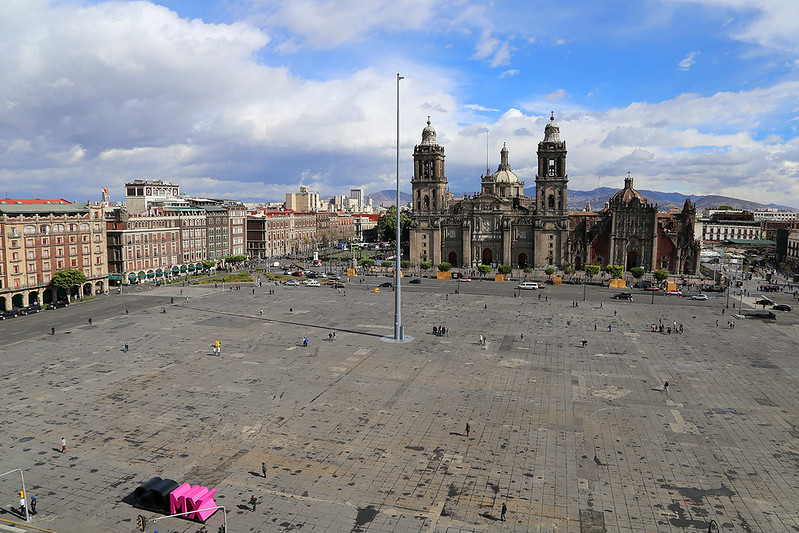Create a short fictional story set in the Zócalo. Under the clear blue sky of the Zócalo, a young musician named Diego set up his guitar and began to play. The plaza was quiet today, with only a few vendors and tourists wandering around. As Diego strummed the strings, his soulful melodies started to draw the attention of passersby.

Among them was an elderly woman who approached slowly, her eyes filled with tears as she listened. She revealed that Diego's song was the sharegpt4v/same one her late husband used to play for her when they were young. Moved by the coincidence, she shared stories of love and memories from her past with Diego. Inspired by her tales, Diego decided to compose a new song, blending elements of her stories with his music, leaving a lasting melody that echoed through the heart of the ancient square. 